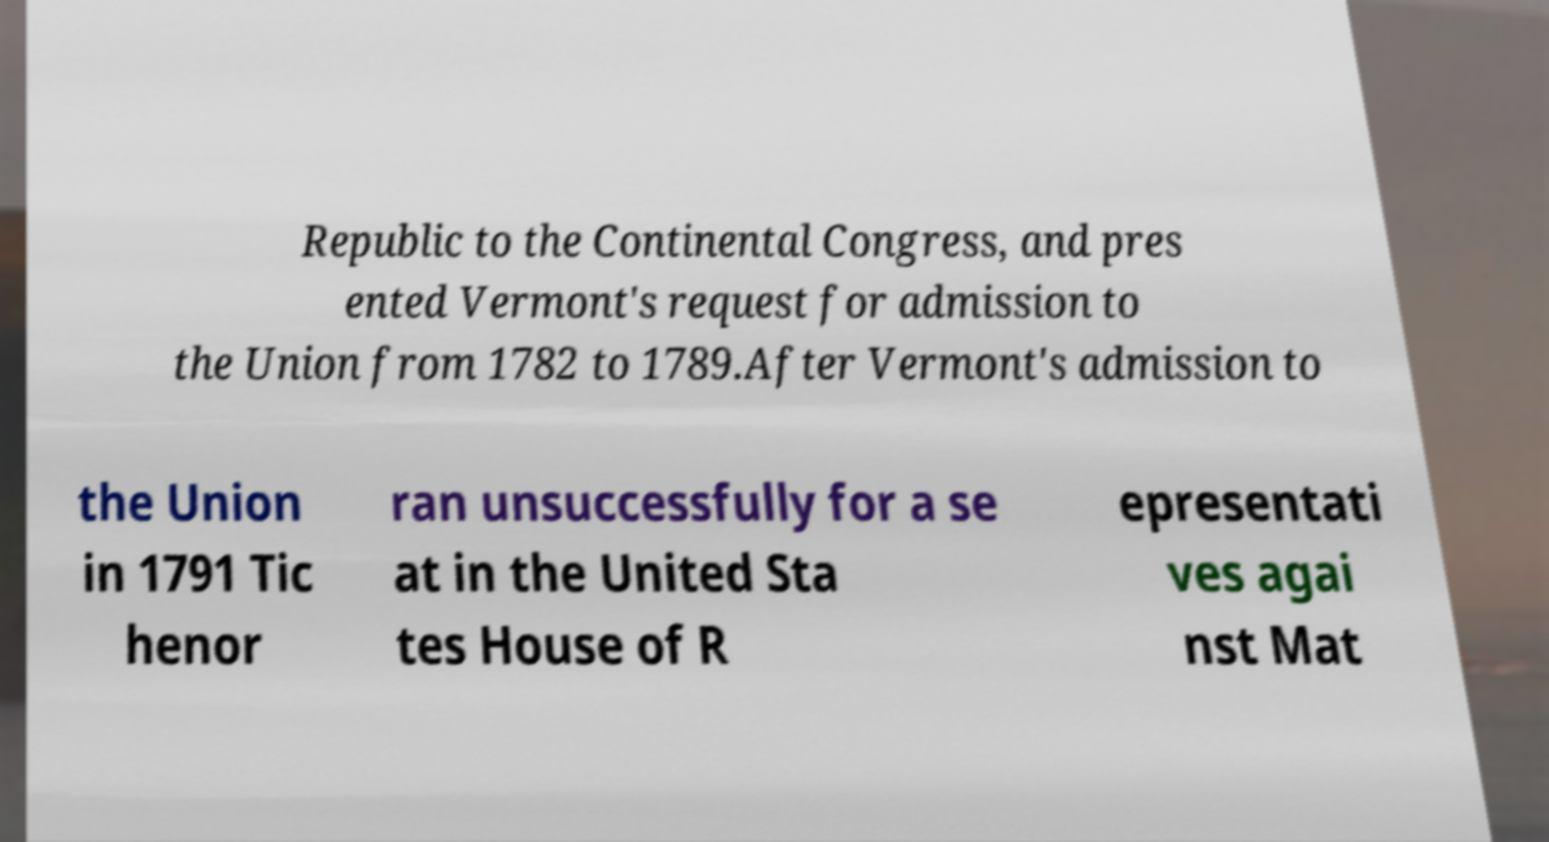I need the written content from this picture converted into text. Can you do that? Republic to the Continental Congress, and pres ented Vermont's request for admission to the Union from 1782 to 1789.After Vermont's admission to the Union in 1791 Tic henor ran unsuccessfully for a se at in the United Sta tes House of R epresentati ves agai nst Mat 